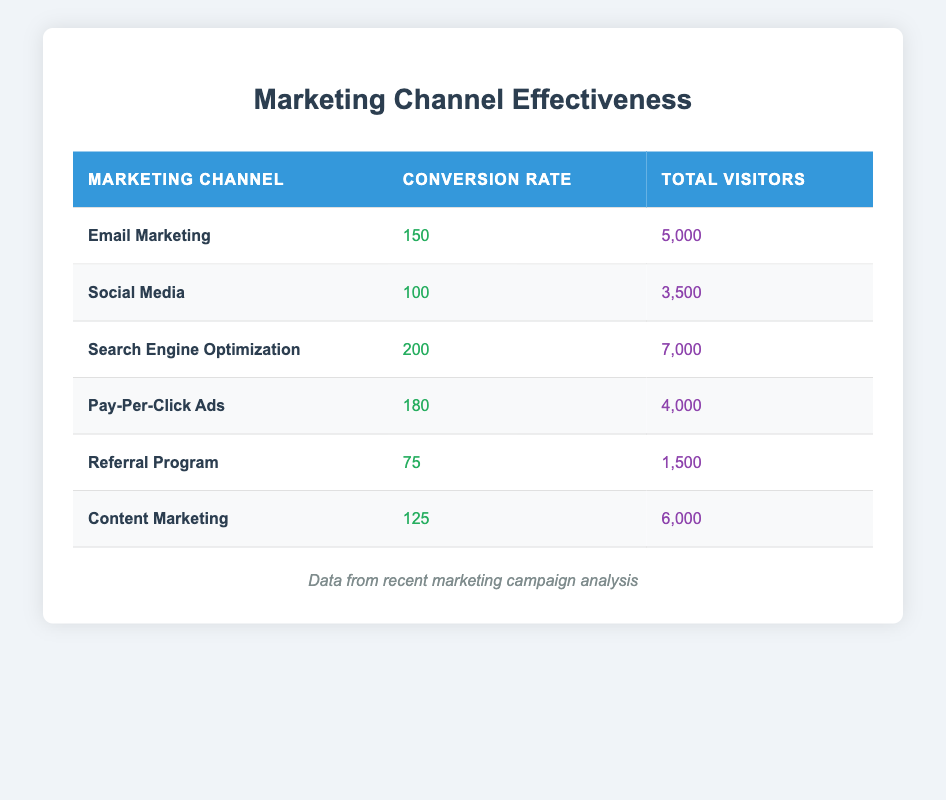What is the conversion rate for Search Engine Optimization? The table shows that the marketing channel "Search Engine Optimization" has a conversion rate of 200.
Answer: 200 Which marketing channel had the highest total visitors? By reviewing the total visitor counts, "Search Engine Optimization" has the highest count at 7000.
Answer: Search Engine Optimization What is the average conversion rate across all marketing channels? To find the average conversion rate, we sum all conversion rates (150 + 100 + 200 + 180 + 75 + 125 = 930) and divide by the number of channels (6), giving us 930/6 = 155.
Answer: 155 Is the conversion rate for Pay-Per-Click Ads greater than the conversion rate for Content Marketing? The conversion rate for Pay-Per-Click Ads is 180, while Content Marketing has a conversion rate of 125. Since 180 is greater than 125, the answer is yes.
Answer: Yes How many total visitors were there for the Email Marketing and Referral Program combined? The total visitors for Email Marketing is 5000 and for Referral Program is 1500. Adding them together (5000 + 1500 = 6500) gives the total visitors combined.
Answer: 6500 What percentage of total visitors came from Social Media? Total visitors from Social Media is 3500. Now, let's find the total visitors across all channels, which equals (5000 + 3500 + 7000 + 4000 + 1500 + 6000 = 28000). The percentage is calculated as (3500 / 28000) * 100 = 12.5%.
Answer: 12.5% Which marketing channel has the least effective conversion rate? Reviewing the conversion rates, the lowest one occurs with the "Referral Program" at a rate of 75.
Answer: Referral Program Are the total visitors for Email Marketing and Pay-Per-Click Ads equal? The table shows 5000 total visitors for Email Marketing and 4000 for Pay-Per-Click Ads. Since these numbers are not equal, the answer is no.
Answer: No 